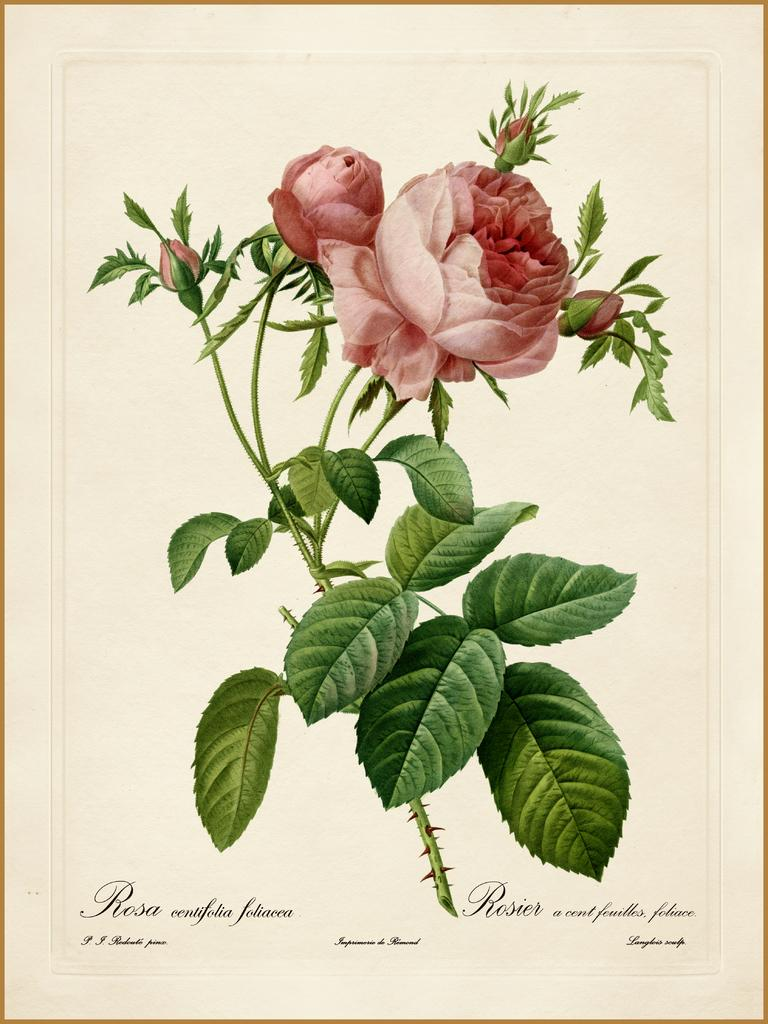What is depicted on the poster in the image? The facts do not specify what is on the poster, so we cannot answer this question definitively. What type of plant is visible in the image? There is a rose plant with leaves and roses in the image. Where is the text located in the image? The text is at the bottom of the image. What type of hair is tied in a knot on the stranger's head in the image? There is no stranger or hair tied in a knot present in the image. 